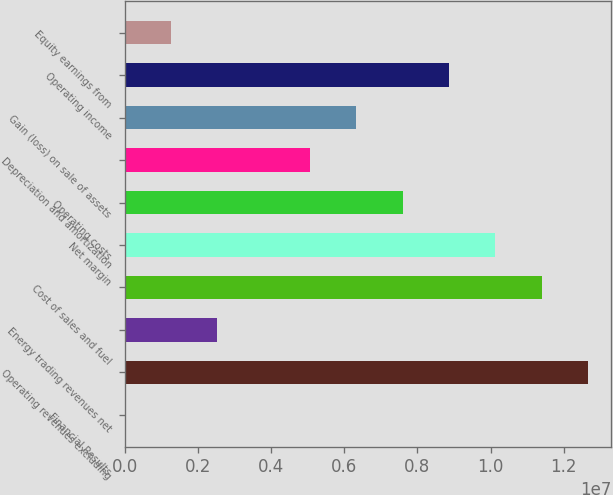Convert chart to OTSL. <chart><loc_0><loc_0><loc_500><loc_500><bar_chart><fcel>Financial Results<fcel>Operating revenues excluding<fcel>Energy trading revenues net<fcel>Cost of sales and fuel<fcel>Net margin<fcel>Operating costs<fcel>Depreciation and amortization<fcel>Gain (loss) on sale of assets<fcel>Operating income<fcel>Equity earnings from<nl><fcel>2005<fcel>1.26636e+07<fcel>2.53431e+06<fcel>1.13974e+07<fcel>1.01312e+07<fcel>7.59893e+06<fcel>5.06662e+06<fcel>6.33278e+06<fcel>8.86509e+06<fcel>1.26816e+06<nl></chart> 